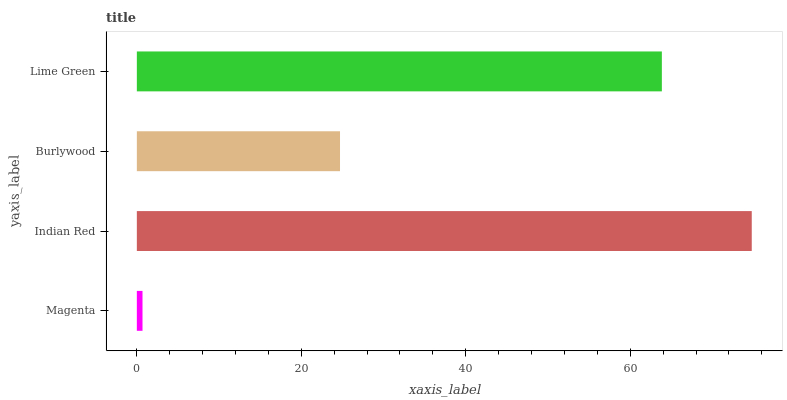Is Magenta the minimum?
Answer yes or no. Yes. Is Indian Red the maximum?
Answer yes or no. Yes. Is Burlywood the minimum?
Answer yes or no. No. Is Burlywood the maximum?
Answer yes or no. No. Is Indian Red greater than Burlywood?
Answer yes or no. Yes. Is Burlywood less than Indian Red?
Answer yes or no. Yes. Is Burlywood greater than Indian Red?
Answer yes or no. No. Is Indian Red less than Burlywood?
Answer yes or no. No. Is Lime Green the high median?
Answer yes or no. Yes. Is Burlywood the low median?
Answer yes or no. Yes. Is Magenta the high median?
Answer yes or no. No. Is Magenta the low median?
Answer yes or no. No. 